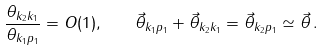<formula> <loc_0><loc_0><loc_500><loc_500>\frac { \theta _ { k _ { 2 } k _ { 1 } } } { \theta _ { k _ { 1 } p _ { 1 } } } = O ( 1 ) , \quad \vec { \theta } _ { k _ { 1 } p _ { 1 } } + \vec { \theta } _ { k _ { 2 } k _ { 1 } } = \vec { \theta } _ { k _ { 2 } p _ { 1 } } \simeq \vec { \theta } \, .</formula> 